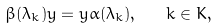Convert formula to latex. <formula><loc_0><loc_0><loc_500><loc_500>\beta ( \lambda _ { k } ) y = y \alpha ( \lambda _ { k } ) , \quad k \in K ,</formula> 